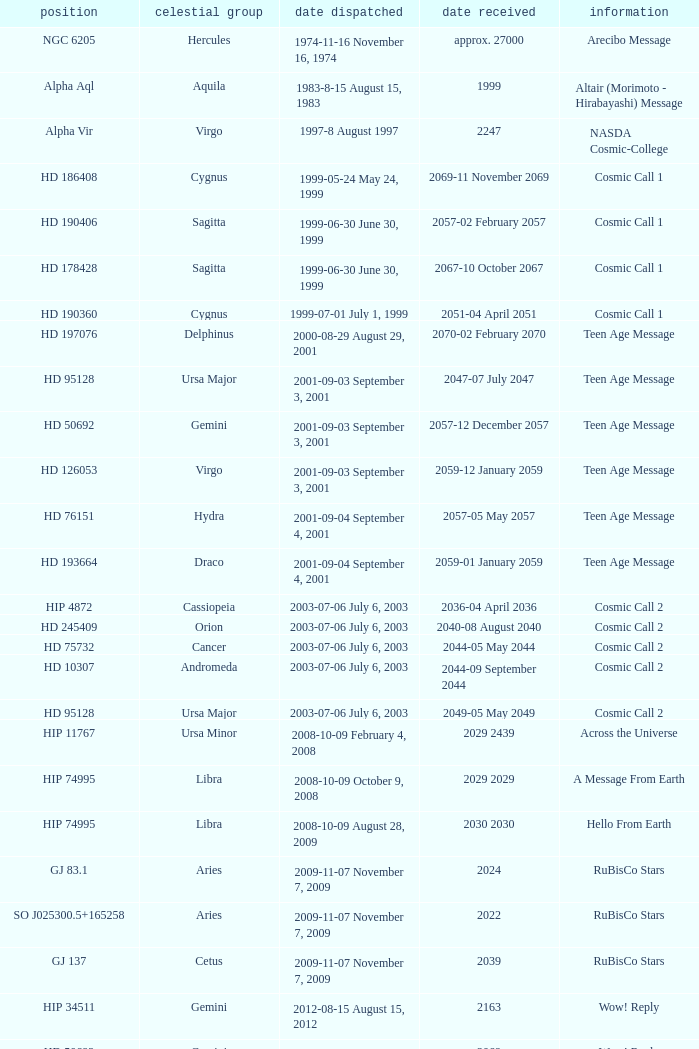Where is Hip 4872? Cassiopeia. 